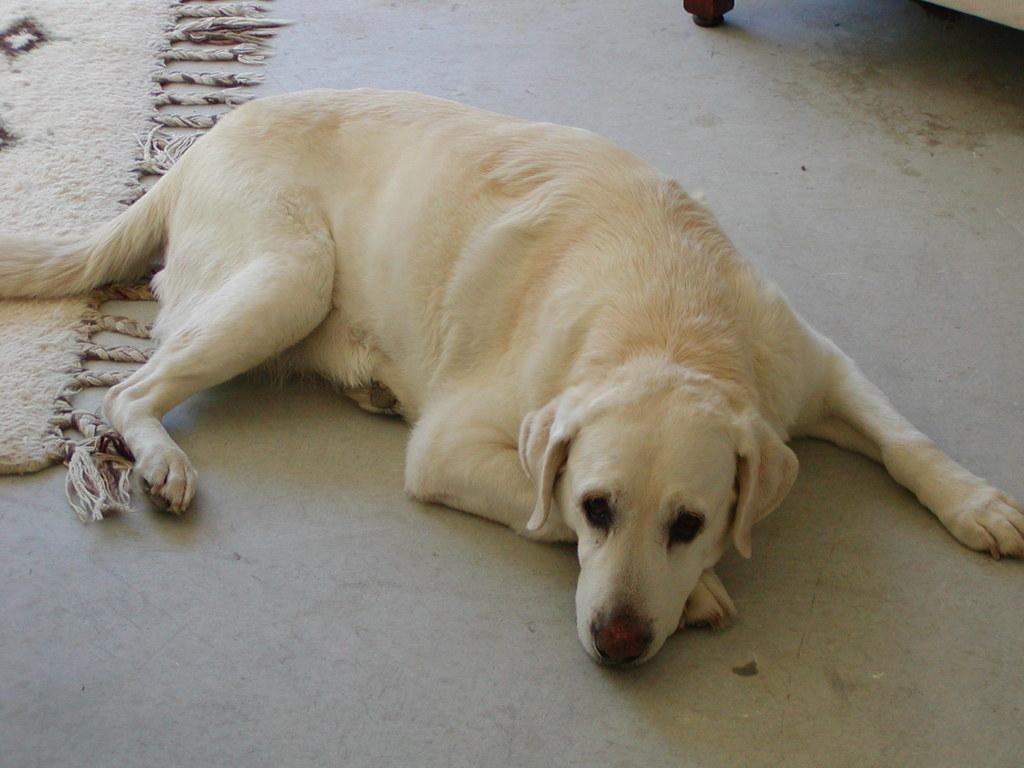What type of animal is in the image? There is a dog in the image. What color is the dog? The dog is white in color. What can be seen on the left side of the image? There is a carpet on the left side of the image. What type of bone is the dog chewing on in the image? There is no bone present in the image; the dog is not chewing on anything. 